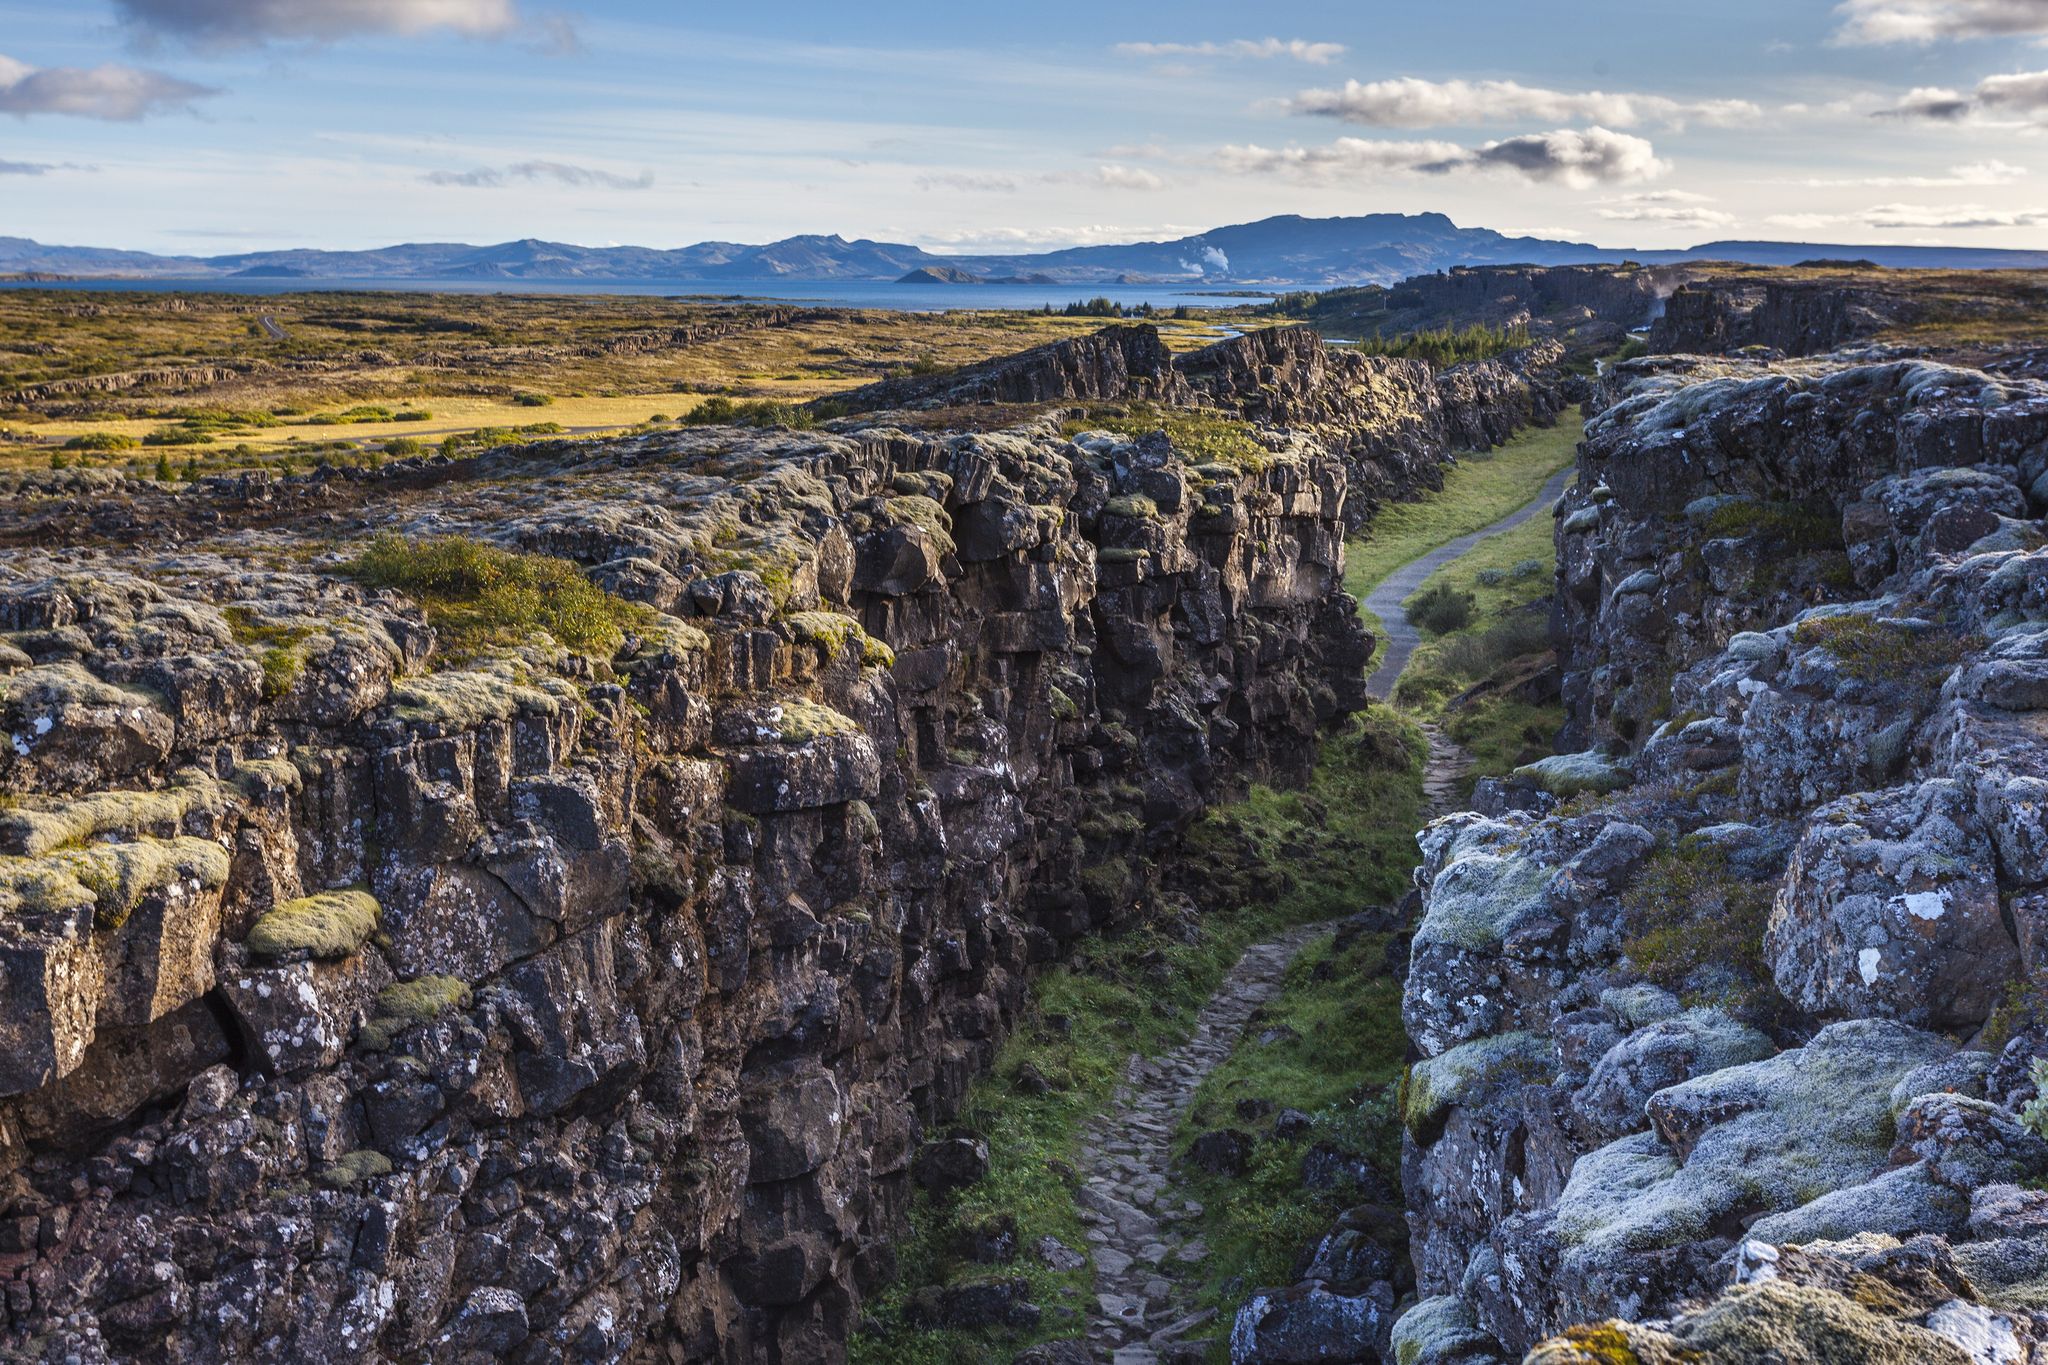Can you describe the geological significance of this location? Þingvellir National Park is a site of immense geological importance. It lies in a rift valley formed by the separation of the Eurasian and North American tectonic plates. This ongoing tectonic activity has created a unique landscape, characterized by deep fissures, cliffs, and valleys. The park showcases the geological process of plate tectonics in a visible and accessible way. One can witness the Mid-Atlantic Ridge above ground at Þingvellir, a rare occurrence, making it a prime location for studying geological rift activity. The visible rift in the photograph is a testament to these powerful natural forces that shape our planet. What activities can visitors engage in at Þingvellir National Park? Visitors to Þingvellir National Park can indulge in a variety of recreational and educational activities. Hiking is a popular choice, with numerous trails that offer breathtaking views and close encounters with the park's geological features. Snorkeling and diving in the Silfra fissure are unique opportunities, allowing adventurers to explore the crystal-clear waters between two continental plates. Historical enthusiasts can visit the site of the ancient Althing, the world's oldest parliament. Additionally, photography, bird watching, and guided tours provide enriching experiences for all visitors. The park's diverse offerings ensure that there's something for everyone to enjoy. Imagine a fantastical creature that could be found in this gorge. Envision a majestic creature known as the 'Aether Drake.' This mythical being is said to inhabit the deep gorges of Þingvellir, its scales shimmering with the colors of the Aurora Borealis. The Aether Drake's presence is revealed by the faint glow it casts on the moss-covered rocks. With wings spanning the length of the cliffs, it glides effortlessly through the rift, its breath exuding a mist that nourishes the lush vegetation. Legend has it that those who spot the Aether Drake are granted a moment of transcendent clarity, understanding the profound connection between the natural world and the cosmos. Describe a warm summer evening scenario in Þingvellir National Park. As the sun begins to set on a warm summer evening at Þingvellir National Park, the sky is painted with hues of orange, pink, and purple. The light casts a golden glow over the rocky cliffs, highlighting the details of the landscape. A gentle breeze rustles through the grasses and wildflowers that dot the floor of the gorge, carrying the scent of fresh earth and blooming flora. Visitors sitting by the tranquil lake watch as the surface of the water mirrors the vibrant colors of the sky, creating a kaleidoscope effect. The distant mountains gradually fade into silhouettes as the first stars begin to appear. The air is filled with a sense of tranquility, and the sounds of nature, from the chirping of birds to the distant flowing water, provide a soothing background symphony. As the twilight deepens, the park transforms into a serene haven, where the beauty of nature takes center stage in the soft, fading light. 